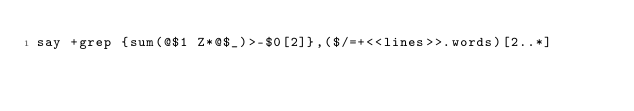<code> <loc_0><loc_0><loc_500><loc_500><_Perl_>say +grep {sum(@$1 Z*@$_)>-$0[2]},($/=+<<lines>>.words)[2..*]</code> 